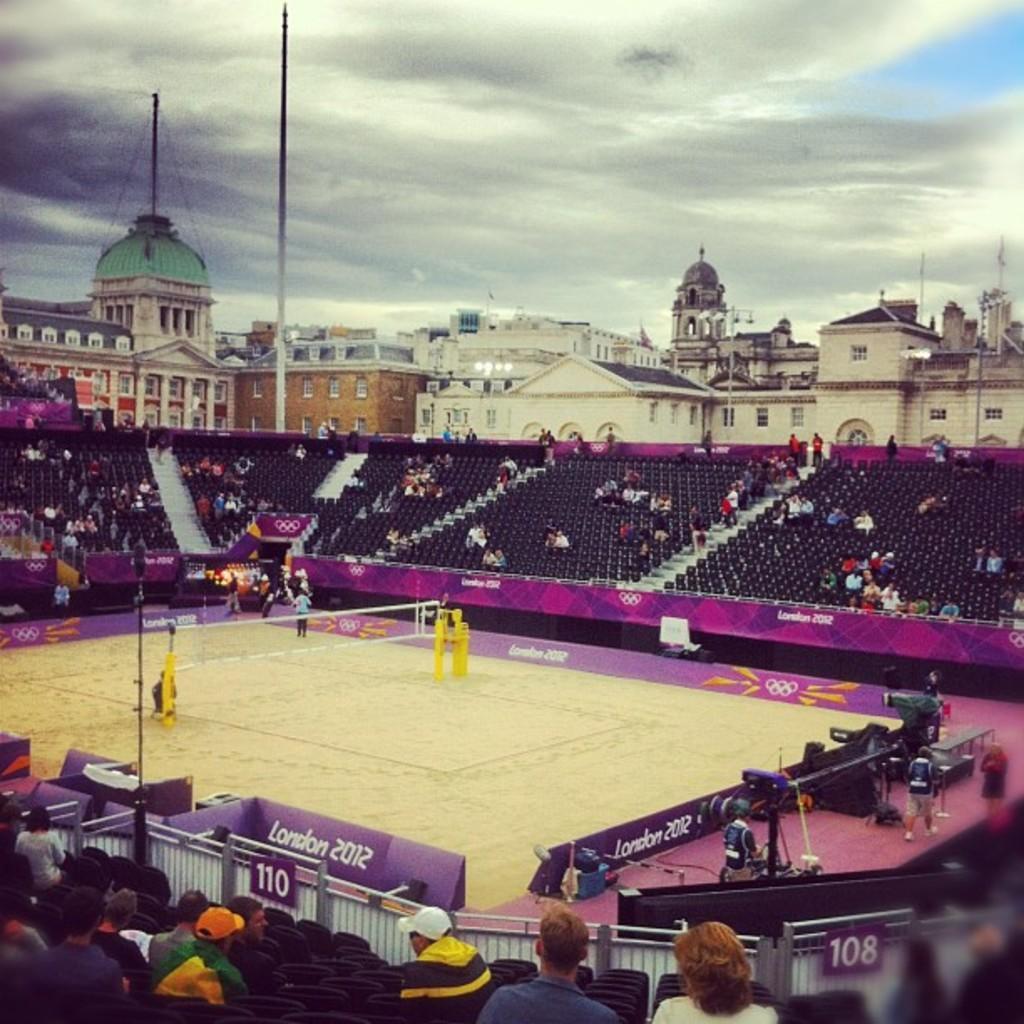Describe this image in one or two sentences. In the foreground of this image, there is a tennis court. In the background, there is a stadium with crowd. on the top, we see buildings, poles, domes, cloud and the sky. 